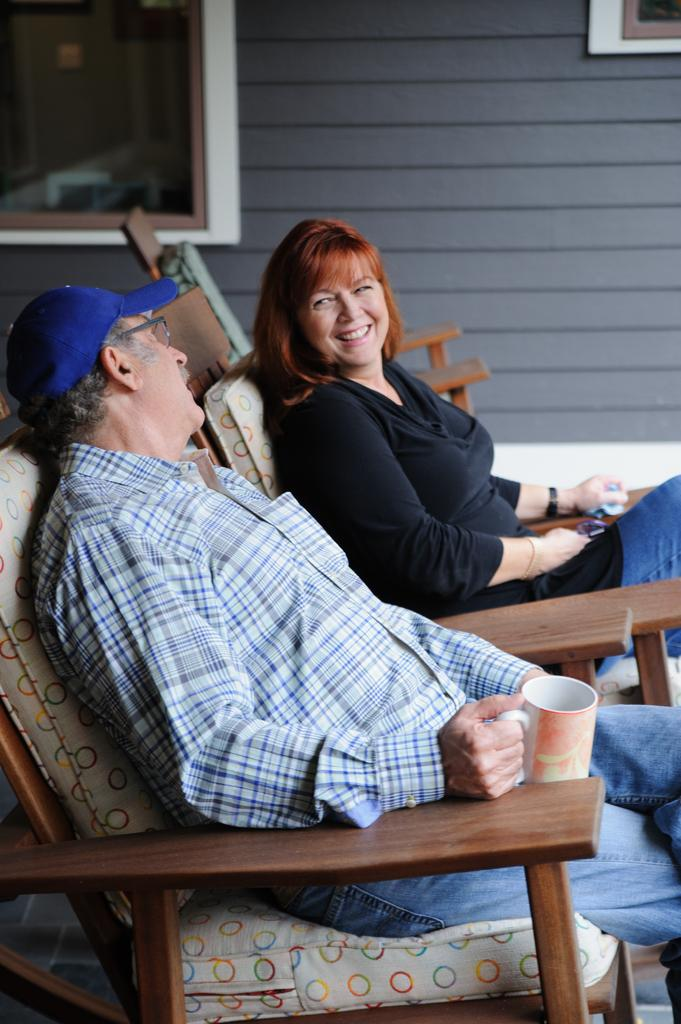What are the people in the image doing? The people in the image are sitting on chairs. Can you describe the chairs in the image? The chairs in the image are brown in color. What can be seen in the background of the image? There is a wall in the background of the image. What color is the wall in the image? The wall in the image is gray in color. Where is the kettle located in the image? There is no kettle present in the image. How many boys are in the image? There is no boy present in the image. 